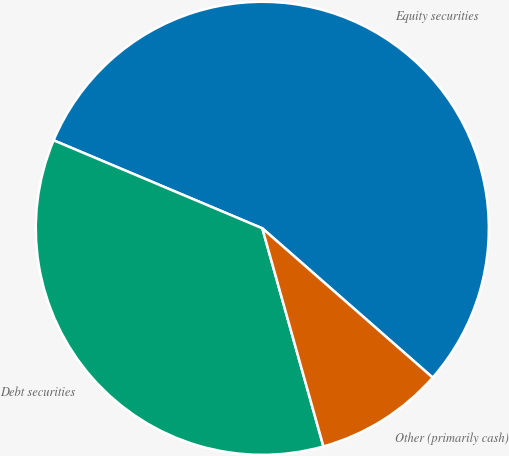Convert chart. <chart><loc_0><loc_0><loc_500><loc_500><pie_chart><fcel>Equity securities<fcel>Debt securities<fcel>Other (primarily cash)<nl><fcel>55.1%<fcel>35.7%<fcel>9.2%<nl></chart> 